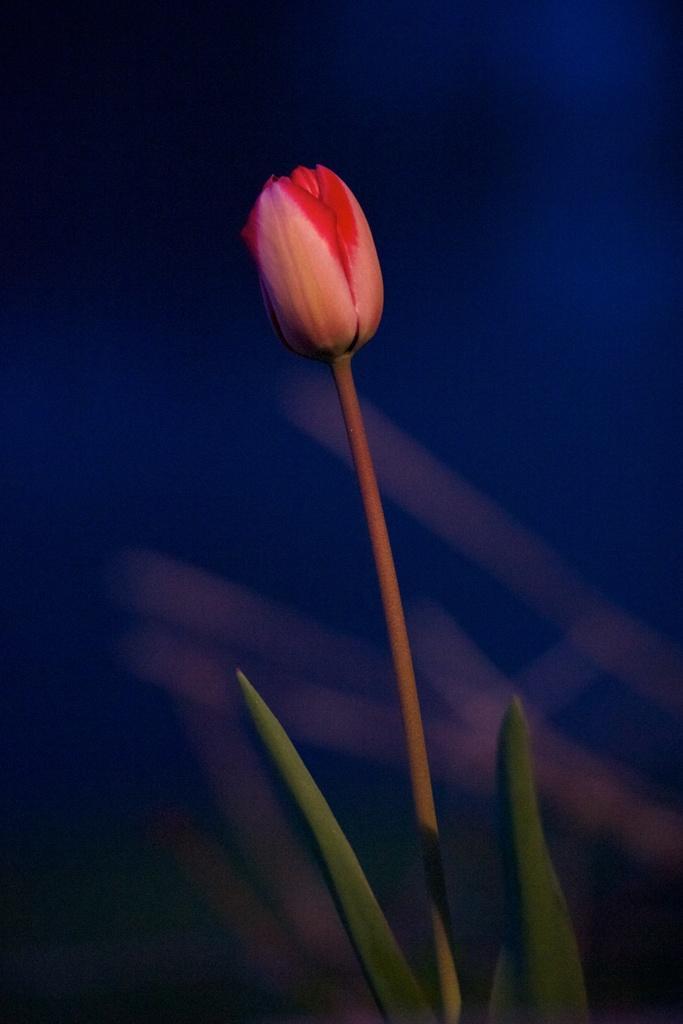In one or two sentences, can you explain what this image depicts? In the middle of the image, there is a plant having a flower and green color leaves. And the background is blurred. 